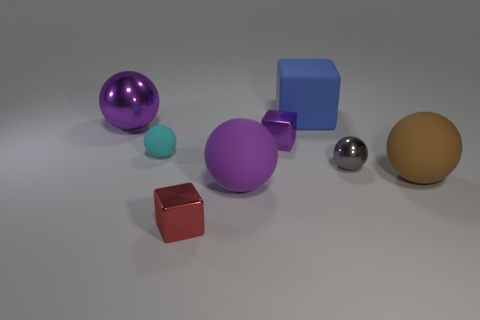How many red metallic blocks are there?
Your response must be concise. 1. What is the color of the metallic ball on the left side of the metal block in front of the small gray shiny object in front of the purple shiny sphere?
Provide a short and direct response. Purple. Is the big cube the same color as the big metal sphere?
Your response must be concise. No. How many shiny spheres are both behind the small purple thing and on the right side of the big metallic thing?
Your answer should be very brief. 0. What number of matte objects are either large blue things or small spheres?
Make the answer very short. 2. There is a big thing left of the purple ball right of the small cyan thing; what is it made of?
Provide a succinct answer. Metal. What is the shape of the small shiny thing that is the same color as the big shiny ball?
Make the answer very short. Cube. What is the shape of the purple thing that is the same size as the red cube?
Provide a succinct answer. Cube. Are there fewer blue matte things than big yellow cylinders?
Offer a terse response. No. There is a tiny block that is in front of the brown thing; are there any blocks to the right of it?
Keep it short and to the point. Yes. 